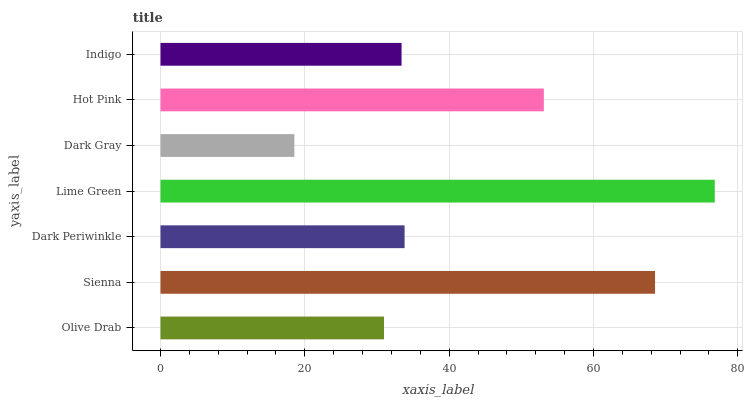Is Dark Gray the minimum?
Answer yes or no. Yes. Is Lime Green the maximum?
Answer yes or no. Yes. Is Sienna the minimum?
Answer yes or no. No. Is Sienna the maximum?
Answer yes or no. No. Is Sienna greater than Olive Drab?
Answer yes or no. Yes. Is Olive Drab less than Sienna?
Answer yes or no. Yes. Is Olive Drab greater than Sienna?
Answer yes or no. No. Is Sienna less than Olive Drab?
Answer yes or no. No. Is Dark Periwinkle the high median?
Answer yes or no. Yes. Is Dark Periwinkle the low median?
Answer yes or no. Yes. Is Sienna the high median?
Answer yes or no. No. Is Hot Pink the low median?
Answer yes or no. No. 